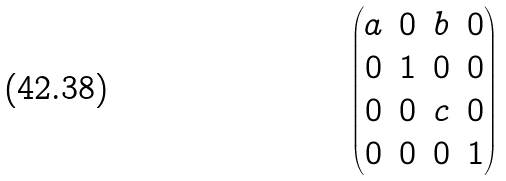<formula> <loc_0><loc_0><loc_500><loc_500>\begin{pmatrix} a & 0 & b & 0 \\ 0 & 1 & 0 & 0 \\ 0 & 0 & c & 0 \\ 0 & 0 & 0 & 1 \end{pmatrix}</formula> 